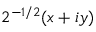<formula> <loc_0><loc_0><loc_500><loc_500>2 ^ { - 1 / 2 } ( x + i y )</formula> 